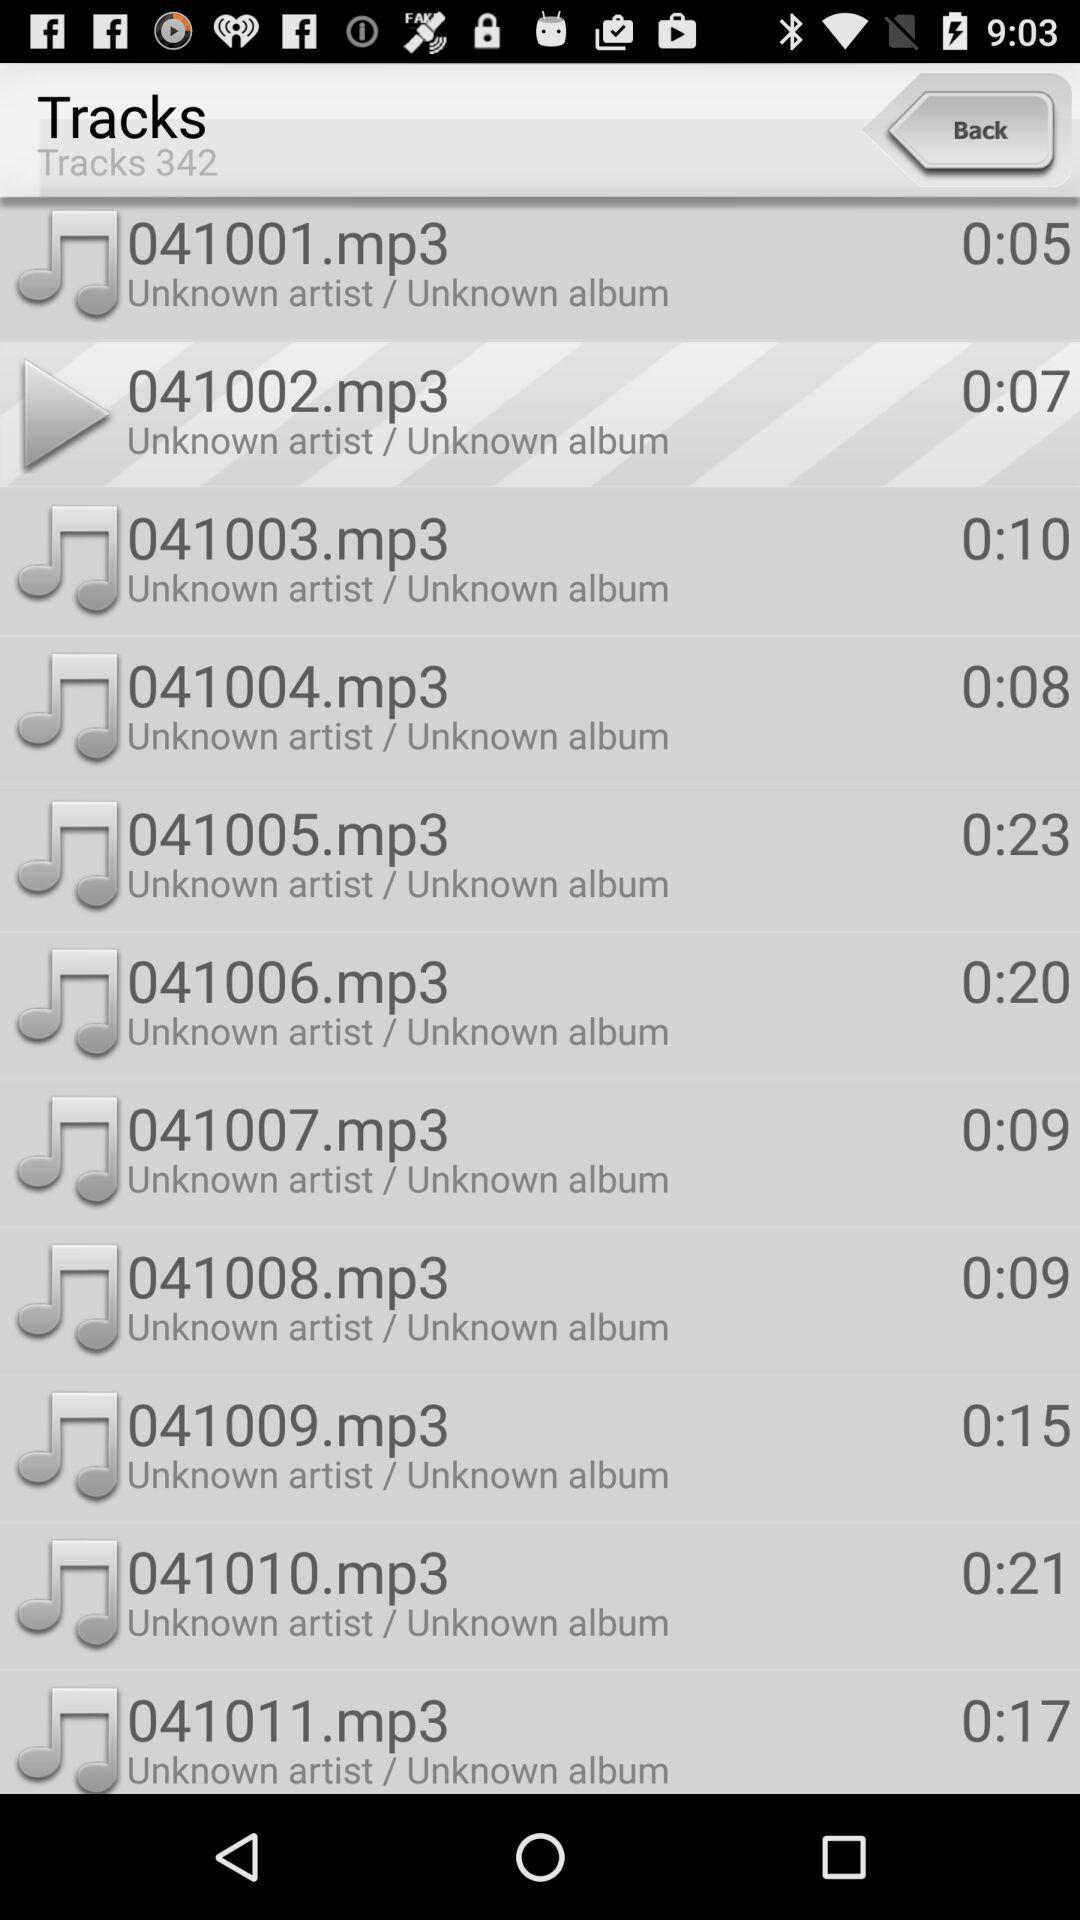What is the duration of the track "041006.mp3"? The duration is 20 seconds. 